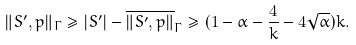Convert formula to latex. <formula><loc_0><loc_0><loc_500><loc_500>\| S ^ { \prime } , p \| _ { \Gamma } \geq | S ^ { \prime } | - \overline { \| S ^ { \prime } , p \| } _ { \Gamma } \geq ( 1 - \alpha - \frac { 4 } { k } - 4 \sqrt { \alpha } ) k .</formula> 